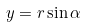<formula> <loc_0><loc_0><loc_500><loc_500>y = r \sin \alpha</formula> 